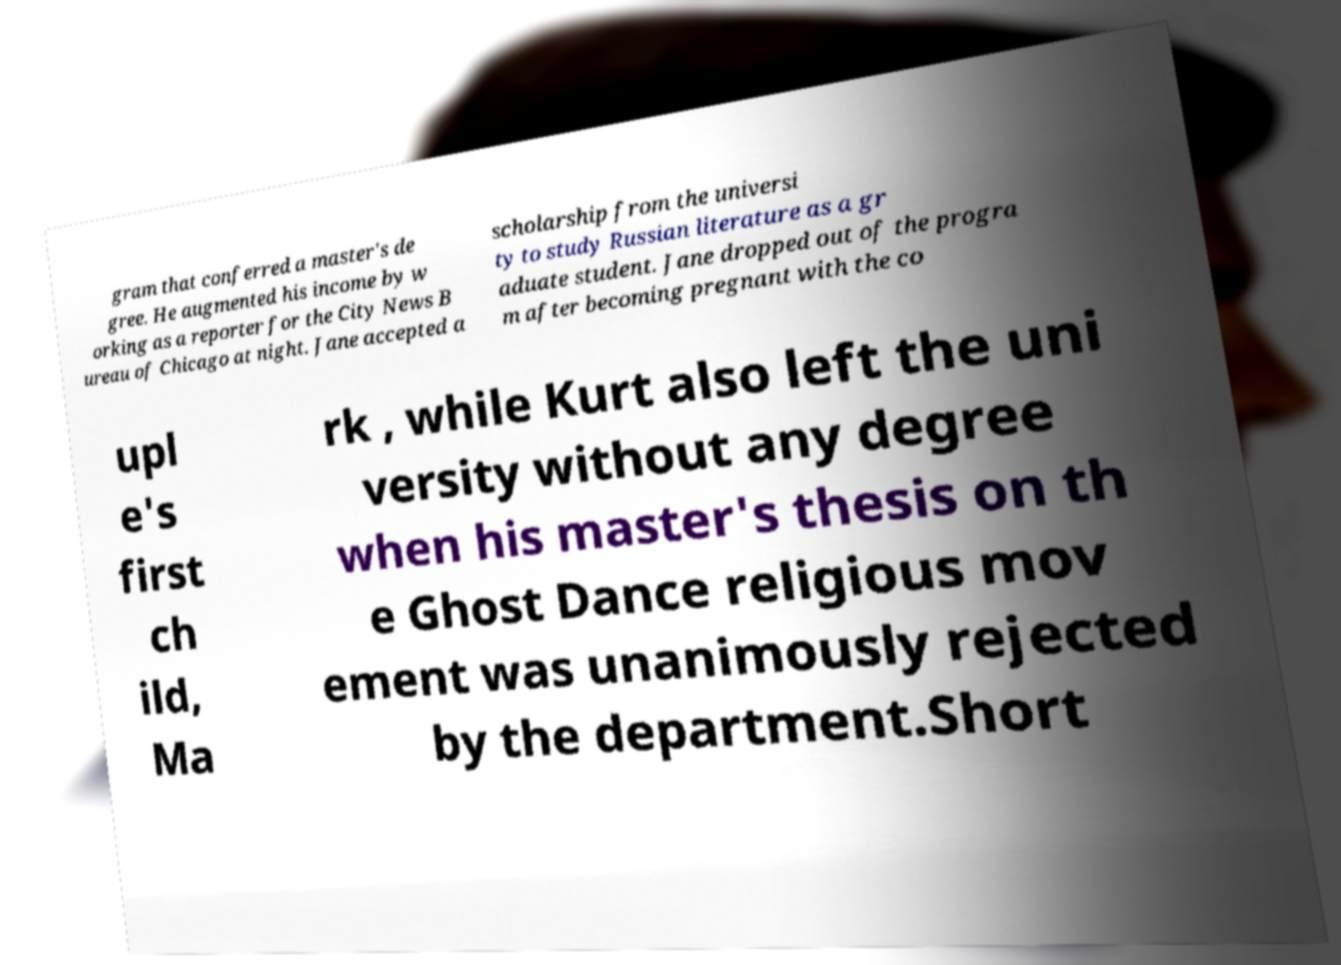What messages or text are displayed in this image? I need them in a readable, typed format. gram that conferred a master's de gree. He augmented his income by w orking as a reporter for the City News B ureau of Chicago at night. Jane accepted a scholarship from the universi ty to study Russian literature as a gr aduate student. Jane dropped out of the progra m after becoming pregnant with the co upl e's first ch ild, Ma rk , while Kurt also left the uni versity without any degree when his master's thesis on th e Ghost Dance religious mov ement was unanimously rejected by the department.Short 